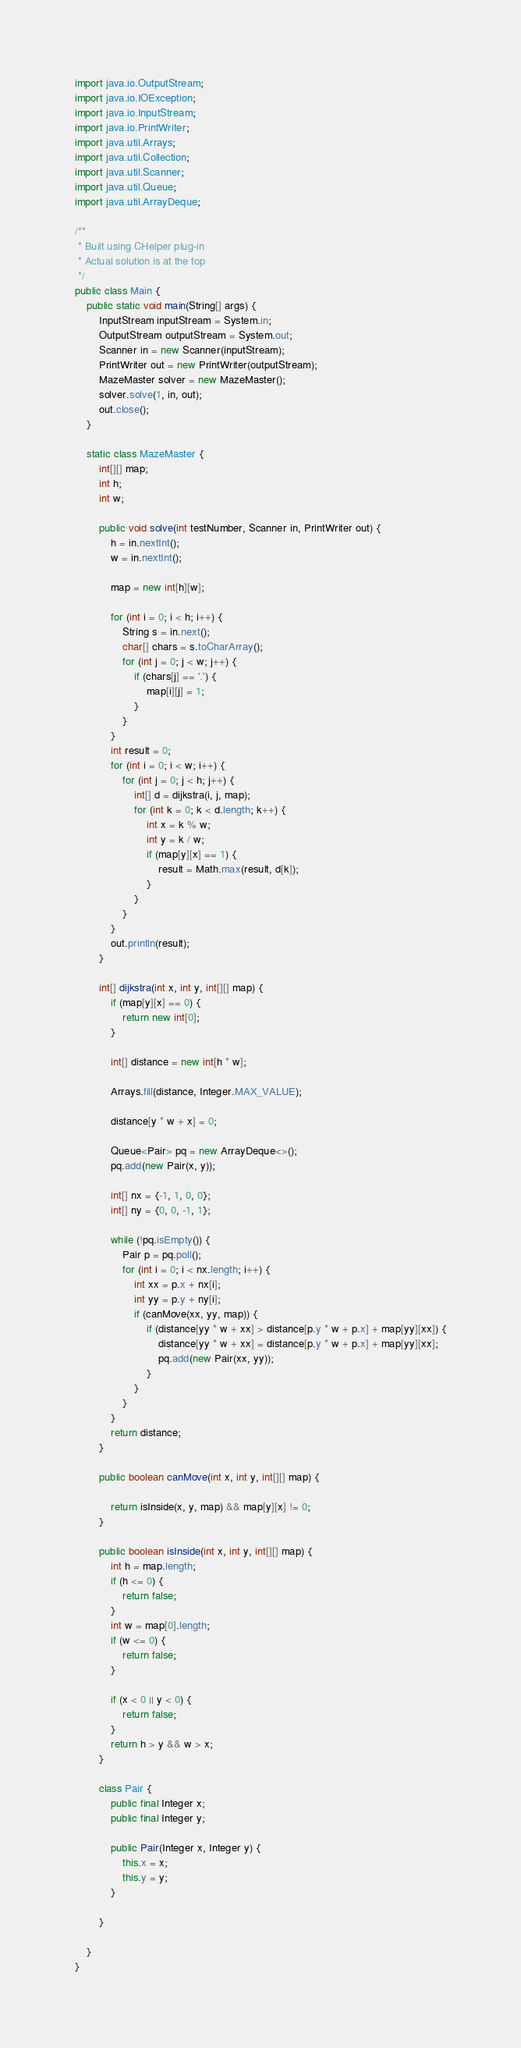Convert code to text. <code><loc_0><loc_0><loc_500><loc_500><_Java_>import java.io.OutputStream;
import java.io.IOException;
import java.io.InputStream;
import java.io.PrintWriter;
import java.util.Arrays;
import java.util.Collection;
import java.util.Scanner;
import java.util.Queue;
import java.util.ArrayDeque;

/**
 * Built using CHelper plug-in
 * Actual solution is at the top
 */
public class Main {
    public static void main(String[] args) {
        InputStream inputStream = System.in;
        OutputStream outputStream = System.out;
        Scanner in = new Scanner(inputStream);
        PrintWriter out = new PrintWriter(outputStream);
        MazeMaster solver = new MazeMaster();
        solver.solve(1, in, out);
        out.close();
    }

    static class MazeMaster {
        int[][] map;
        int h;
        int w;

        public void solve(int testNumber, Scanner in, PrintWriter out) {
            h = in.nextInt();
            w = in.nextInt();

            map = new int[h][w];

            for (int i = 0; i < h; i++) {
                String s = in.next();
                char[] chars = s.toCharArray();
                for (int j = 0; j < w; j++) {
                    if (chars[j] == '.') {
                        map[i][j] = 1;
                    }
                }
            }
            int result = 0;
            for (int i = 0; i < w; i++) {
                for (int j = 0; j < h; j++) {
                    int[] d = dijkstra(i, j, map);
                    for (int k = 0; k < d.length; k++) {
                        int x = k % w;
                        int y = k / w;
                        if (map[y][x] == 1) {
                            result = Math.max(result, d[k]);
                        }
                    }
                }
            }
            out.println(result);
        }

        int[] dijkstra(int x, int y, int[][] map) {
            if (map[y][x] == 0) {
                return new int[0];
            }

            int[] distance = new int[h * w];

            Arrays.fill(distance, Integer.MAX_VALUE);

            distance[y * w + x] = 0;

            Queue<Pair> pq = new ArrayDeque<>();
            pq.add(new Pair(x, y));

            int[] nx = {-1, 1, 0, 0};
            int[] ny = {0, 0, -1, 1};

            while (!pq.isEmpty()) {
                Pair p = pq.poll();
                for (int i = 0; i < nx.length; i++) {
                    int xx = p.x + nx[i];
                    int yy = p.y + ny[i];
                    if (canMove(xx, yy, map)) {
                        if (distance[yy * w + xx] > distance[p.y * w + p.x] + map[yy][xx]) {
                            distance[yy * w + xx] = distance[p.y * w + p.x] + map[yy][xx];
                            pq.add(new Pair(xx, yy));
                        }
                    }
                }
            }
            return distance;
        }

        public boolean canMove(int x, int y, int[][] map) {

            return isInside(x, y, map) && map[y][x] != 0;
        }

        public boolean isInside(int x, int y, int[][] map) {
            int h = map.length;
            if (h <= 0) {
                return false;
            }
            int w = map[0].length;
            if (w <= 0) {
                return false;
            }

            if (x < 0 || y < 0) {
                return false;
            }
            return h > y && w > x;
        }

        class Pair {
            public final Integer x;
            public final Integer y;

            public Pair(Integer x, Integer y) {
                this.x = x;
                this.y = y;
            }

        }

    }
}

</code> 